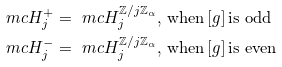Convert formula to latex. <formula><loc_0><loc_0><loc_500><loc_500>\ m c { H } ^ { + } _ { j } & = \ m c { H } ^ { \mathbb { Z } / j \mathbb { Z } _ { \alpha } } _ { j } , \, \text {when} \, [ g ] \, \text {is odd} \\ \ m c { H } ^ { - } _ { j } & = \ m c { H } ^ { \mathbb { Z } / j \mathbb { Z } _ { \alpha } } _ { j } , \, \text {when} \, [ g ] \, \text {is even}</formula> 